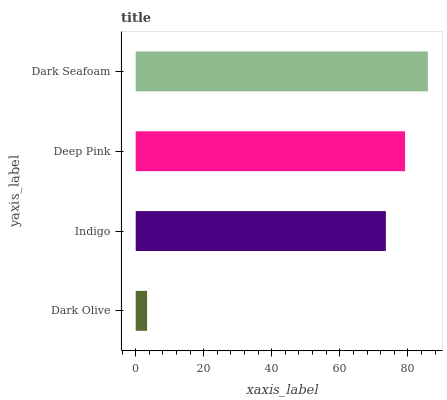Is Dark Olive the minimum?
Answer yes or no. Yes. Is Dark Seafoam the maximum?
Answer yes or no. Yes. Is Indigo the minimum?
Answer yes or no. No. Is Indigo the maximum?
Answer yes or no. No. Is Indigo greater than Dark Olive?
Answer yes or no. Yes. Is Dark Olive less than Indigo?
Answer yes or no. Yes. Is Dark Olive greater than Indigo?
Answer yes or no. No. Is Indigo less than Dark Olive?
Answer yes or no. No. Is Deep Pink the high median?
Answer yes or no. Yes. Is Indigo the low median?
Answer yes or no. Yes. Is Dark Seafoam the high median?
Answer yes or no. No. Is Deep Pink the low median?
Answer yes or no. No. 